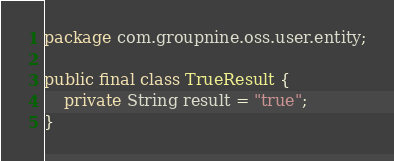Convert code to text. <code><loc_0><loc_0><loc_500><loc_500><_Java_>package com.groupnine.oss.user.entity;

public final class TrueResult {
    private String result = "true";
}
</code> 